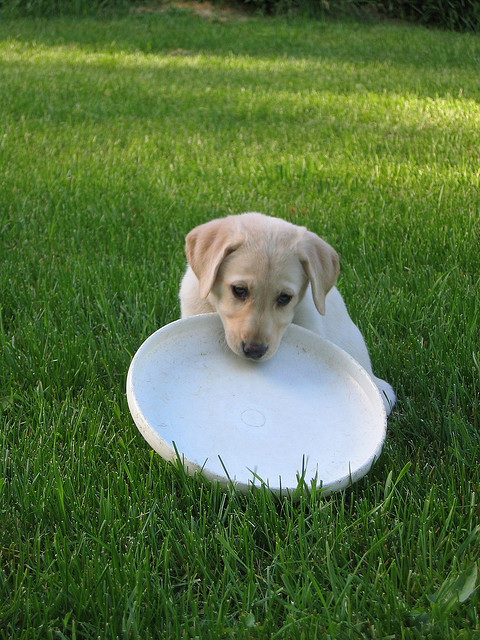<image>Does a woman throw the Frisbee? It is unknown if a woman threw the Frisbee. Does a woman throw the Frisbee? It is unknown if a woman throws the Frisbee. It can be seen as 'no'. 